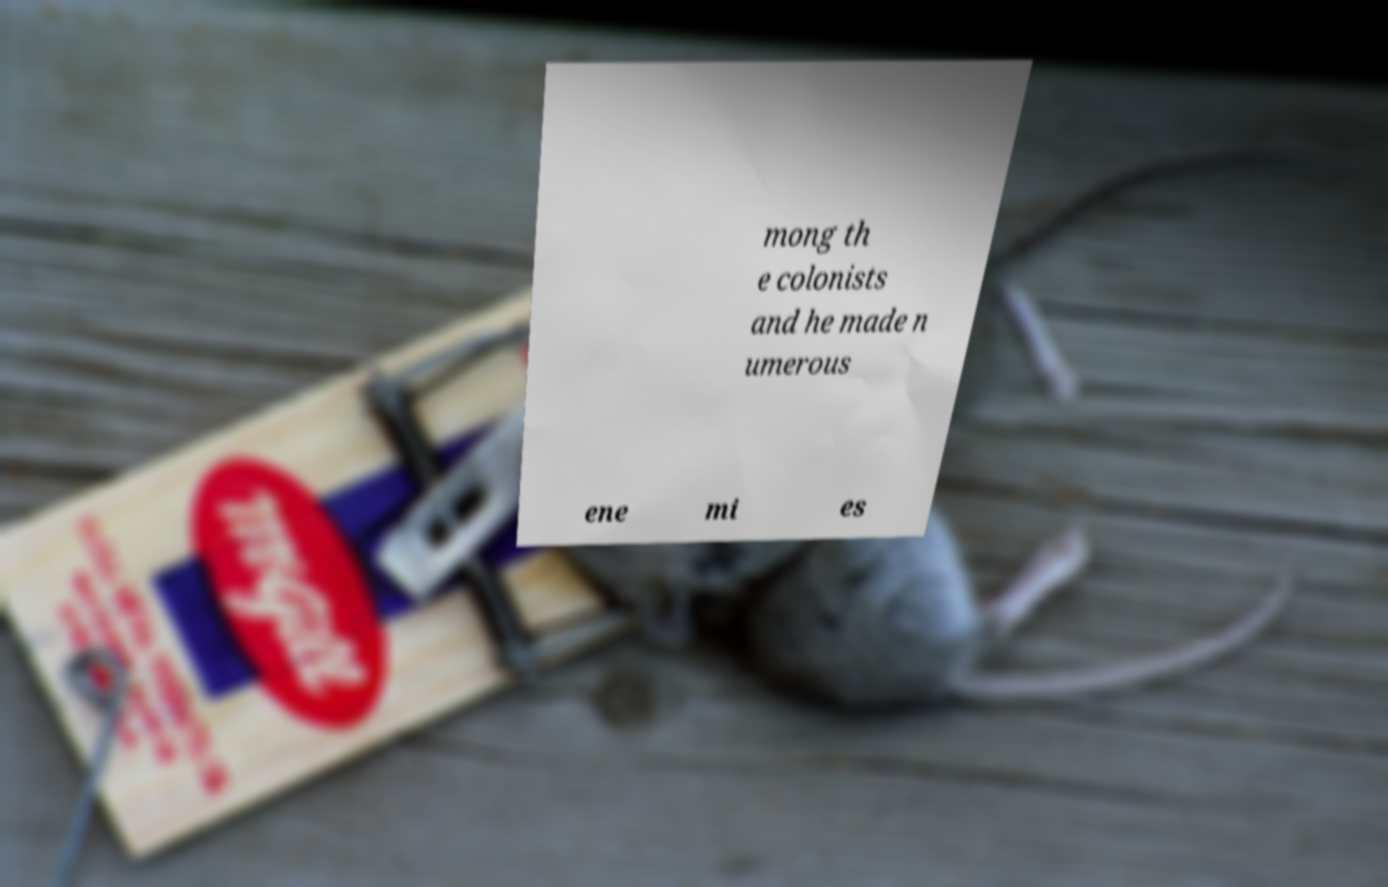For documentation purposes, I need the text within this image transcribed. Could you provide that? mong th e colonists and he made n umerous ene mi es 